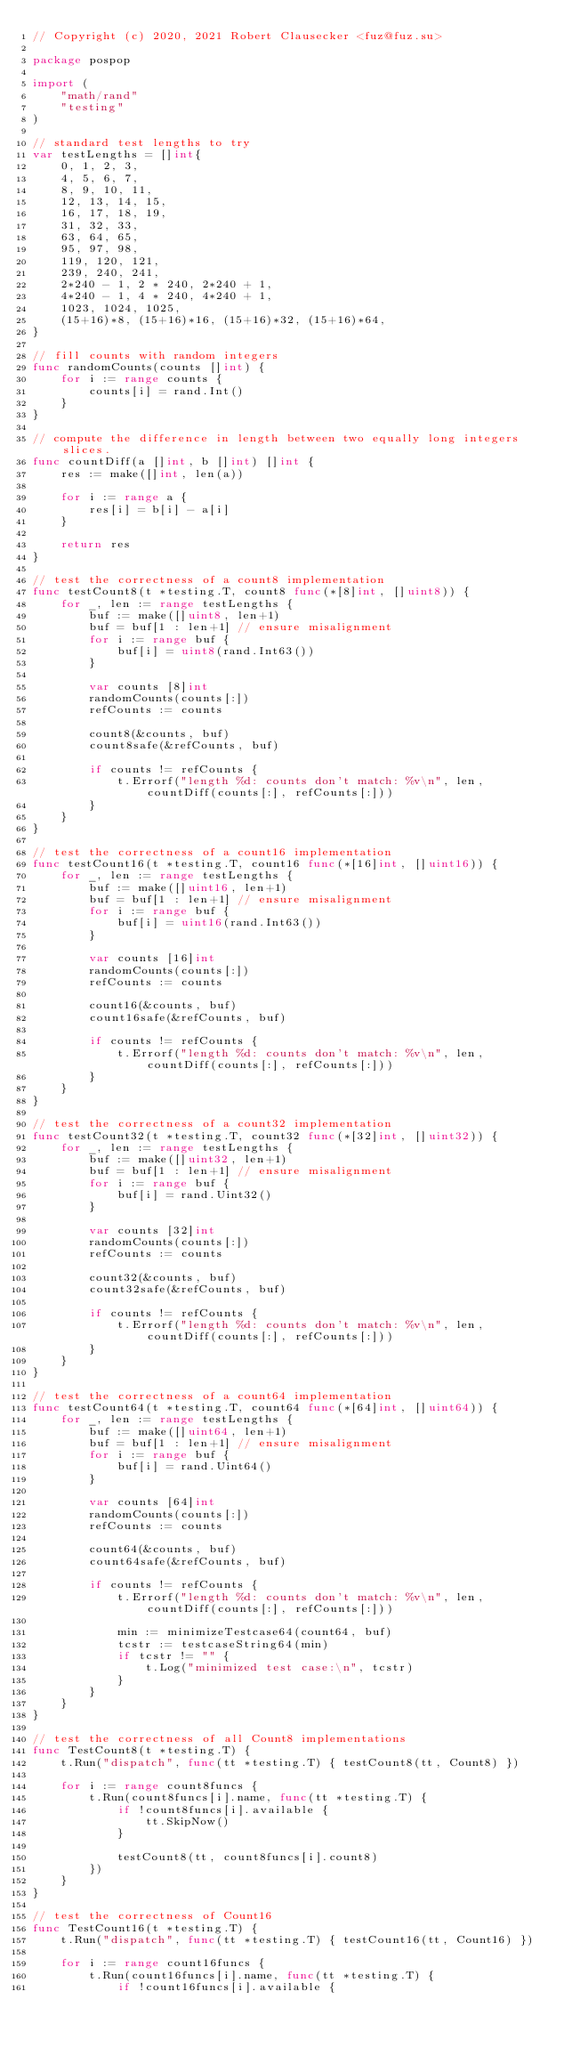<code> <loc_0><loc_0><loc_500><loc_500><_Go_>// Copyright (c) 2020, 2021 Robert Clausecker <fuz@fuz.su>

package pospop

import (
	"math/rand"
	"testing"
)

// standard test lengths to try
var testLengths = []int{
	0, 1, 2, 3,
	4, 5, 6, 7,
	8, 9, 10, 11,
	12, 13, 14, 15,
	16, 17, 18, 19,
	31, 32, 33,
	63, 64, 65,
	95, 97, 98,
	119, 120, 121,
	239, 240, 241,
	2*240 - 1, 2 * 240, 2*240 + 1,
	4*240 - 1, 4 * 240, 4*240 + 1,
	1023, 1024, 1025,
	(15+16)*8, (15+16)*16, (15+16)*32, (15+16)*64,
}

// fill counts with random integers
func randomCounts(counts []int) {
	for i := range counts {
		counts[i] = rand.Int()
	}
}

// compute the difference in length between two equally long integers slices.
func countDiff(a []int, b []int) []int {
	res := make([]int, len(a))

	for i := range a {
		res[i] = b[i] - a[i]
	}

	return res
}

// test the correctness of a count8 implementation
func testCount8(t *testing.T, count8 func(*[8]int, []uint8)) {
	for _, len := range testLengths {
		buf := make([]uint8, len+1)
		buf = buf[1 : len+1] // ensure misalignment
		for i := range buf {
			buf[i] = uint8(rand.Int63())
		}

		var counts [8]int
		randomCounts(counts[:])
		refCounts := counts

		count8(&counts, buf)
		count8safe(&refCounts, buf)

		if counts != refCounts {
			t.Errorf("length %d: counts don't match: %v\n", len, countDiff(counts[:], refCounts[:]))
		}
	}
}

// test the correctness of a count16 implementation
func testCount16(t *testing.T, count16 func(*[16]int, []uint16)) {
	for _, len := range testLengths {
		buf := make([]uint16, len+1)
		buf = buf[1 : len+1] // ensure misalignment
		for i := range buf {
			buf[i] = uint16(rand.Int63())
		}

		var counts [16]int
		randomCounts(counts[:])
		refCounts := counts

		count16(&counts, buf)
		count16safe(&refCounts, buf)

		if counts != refCounts {
			t.Errorf("length %d: counts don't match: %v\n", len, countDiff(counts[:], refCounts[:]))
		}
	}
}

// test the correctness of a count32 implementation
func testCount32(t *testing.T, count32 func(*[32]int, []uint32)) {
	for _, len := range testLengths {
		buf := make([]uint32, len+1)
		buf = buf[1 : len+1] // ensure misalignment
		for i := range buf {
			buf[i] = rand.Uint32()
		}

		var counts [32]int
		randomCounts(counts[:])
		refCounts := counts

		count32(&counts, buf)
		count32safe(&refCounts, buf)

		if counts != refCounts {
			t.Errorf("length %d: counts don't match: %v\n", len, countDiff(counts[:], refCounts[:]))
		}
	}
}

// test the correctness of a count64 implementation
func testCount64(t *testing.T, count64 func(*[64]int, []uint64)) {
	for _, len := range testLengths {
		buf := make([]uint64, len+1)
		buf = buf[1 : len+1] // ensure misalignment
		for i := range buf {
			buf[i] = rand.Uint64()
		}

		var counts [64]int
		randomCounts(counts[:])
		refCounts := counts

		count64(&counts, buf)
		count64safe(&refCounts, buf)

		if counts != refCounts {
			t.Errorf("length %d: counts don't match: %v\n", len, countDiff(counts[:], refCounts[:]))

			min := minimizeTestcase64(count64, buf)
			tcstr := testcaseString64(min)
			if tcstr != "" {
				t.Log("minimized test case:\n", tcstr)
			}
		}
	}
}

// test the correctness of all Count8 implementations
func TestCount8(t *testing.T) {
	t.Run("dispatch", func(tt *testing.T) { testCount8(tt, Count8) })

	for i := range count8funcs {
		t.Run(count8funcs[i].name, func(tt *testing.T) {
			if !count8funcs[i].available {
				tt.SkipNow()
			}

			testCount8(tt, count8funcs[i].count8)
		})
	}
}

// test the correctness of Count16
func TestCount16(t *testing.T) {
	t.Run("dispatch", func(tt *testing.T) { testCount16(tt, Count16) })

	for i := range count16funcs {
		t.Run(count16funcs[i].name, func(tt *testing.T) {
			if !count16funcs[i].available {</code> 